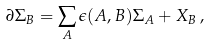<formula> <loc_0><loc_0><loc_500><loc_500>\partial \Sigma _ { B } = \sum _ { A } \epsilon ( A , B ) \Sigma _ { A } + X _ { B } \, ,</formula> 